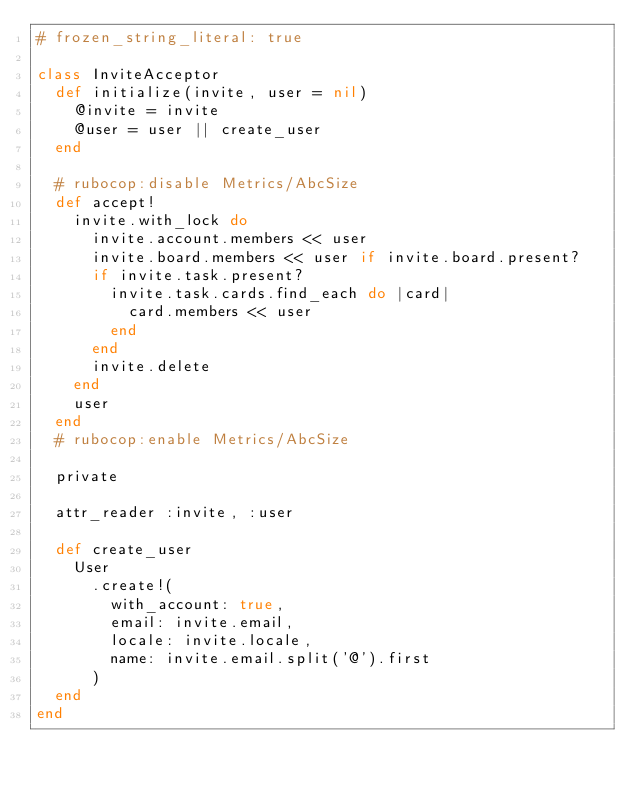<code> <loc_0><loc_0><loc_500><loc_500><_Ruby_># frozen_string_literal: true

class InviteAcceptor
  def initialize(invite, user = nil)
    @invite = invite
    @user = user || create_user
  end

  # rubocop:disable Metrics/AbcSize
  def accept!
    invite.with_lock do
      invite.account.members << user
      invite.board.members << user if invite.board.present?
      if invite.task.present?
        invite.task.cards.find_each do |card|
          card.members << user
        end
      end
      invite.delete
    end
    user
  end
  # rubocop:enable Metrics/AbcSize

  private

  attr_reader :invite, :user

  def create_user
    User
      .create!(
        with_account: true,
        email: invite.email,
        locale: invite.locale,
        name: invite.email.split('@').first
      )
  end
end
</code> 